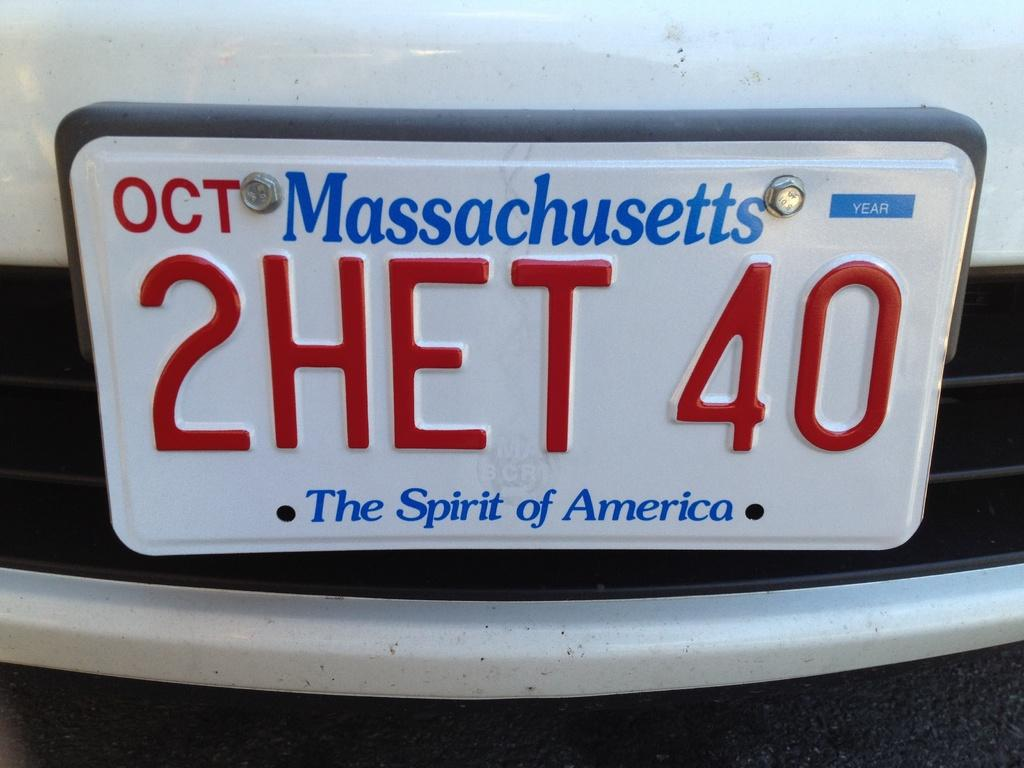<image>
Present a compact description of the photo's key features. A license plate of a car coming from Massachusetts. 